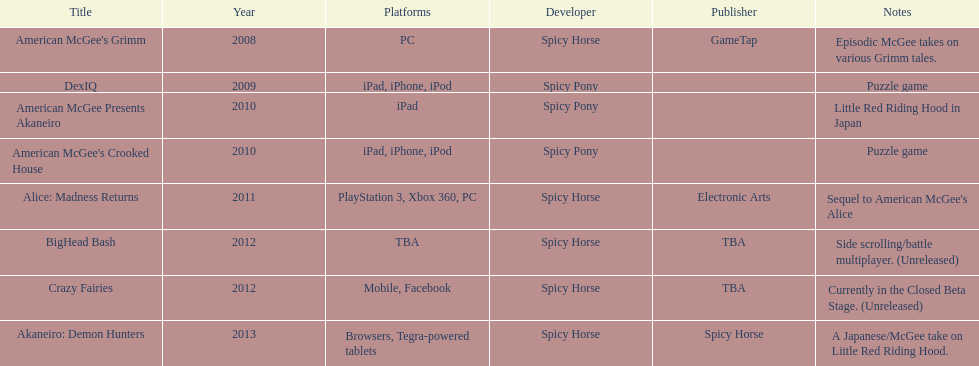How many platforms did american mcgee's grimm run on? 1. 